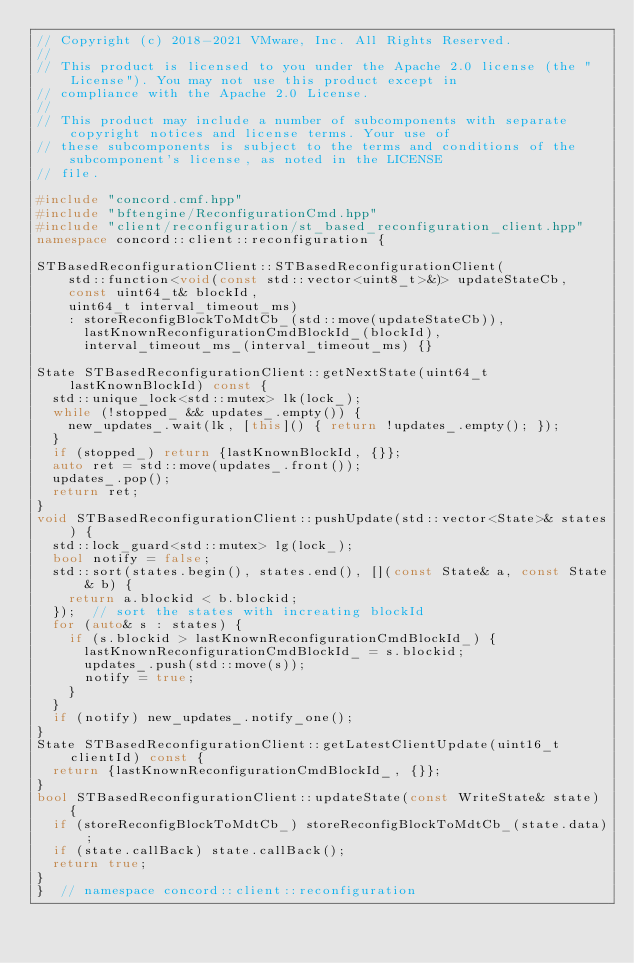Convert code to text. <code><loc_0><loc_0><loc_500><loc_500><_C++_>// Copyright (c) 2018-2021 VMware, Inc. All Rights Reserved.
//
// This product is licensed to you under the Apache 2.0 license (the "License"). You may not use this product except in
// compliance with the Apache 2.0 License.
//
// This product may include a number of subcomponents with separate copyright notices and license terms. Your use of
// these subcomponents is subject to the terms and conditions of the subcomponent's license, as noted in the LICENSE
// file.

#include "concord.cmf.hpp"
#include "bftengine/ReconfigurationCmd.hpp"
#include "client/reconfiguration/st_based_reconfiguration_client.hpp"
namespace concord::client::reconfiguration {

STBasedReconfigurationClient::STBasedReconfigurationClient(
    std::function<void(const std::vector<uint8_t>&)> updateStateCb,
    const uint64_t& blockId,
    uint64_t interval_timeout_ms)
    : storeReconfigBlockToMdtCb_(std::move(updateStateCb)),
      lastKnownReconfigurationCmdBlockId_(blockId),
      interval_timeout_ms_(interval_timeout_ms) {}

State STBasedReconfigurationClient::getNextState(uint64_t lastKnownBlockId) const {
  std::unique_lock<std::mutex> lk(lock_);
  while (!stopped_ && updates_.empty()) {
    new_updates_.wait(lk, [this]() { return !updates_.empty(); });
  }
  if (stopped_) return {lastKnownBlockId, {}};
  auto ret = std::move(updates_.front());
  updates_.pop();
  return ret;
}
void STBasedReconfigurationClient::pushUpdate(std::vector<State>& states) {
  std::lock_guard<std::mutex> lg(lock_);
  bool notify = false;
  std::sort(states.begin(), states.end(), [](const State& a, const State& b) {
    return a.blockid < b.blockid;
  });  // sort the states with increating blockId
  for (auto& s : states) {
    if (s.blockid > lastKnownReconfigurationCmdBlockId_) {
      lastKnownReconfigurationCmdBlockId_ = s.blockid;
      updates_.push(std::move(s));
      notify = true;
    }
  }
  if (notify) new_updates_.notify_one();
}
State STBasedReconfigurationClient::getLatestClientUpdate(uint16_t clientId) const {
  return {lastKnownReconfigurationCmdBlockId_, {}};
}
bool STBasedReconfigurationClient::updateState(const WriteState& state) {
  if (storeReconfigBlockToMdtCb_) storeReconfigBlockToMdtCb_(state.data);
  if (state.callBack) state.callBack();
  return true;
}
}  // namespace concord::client::reconfiguration</code> 